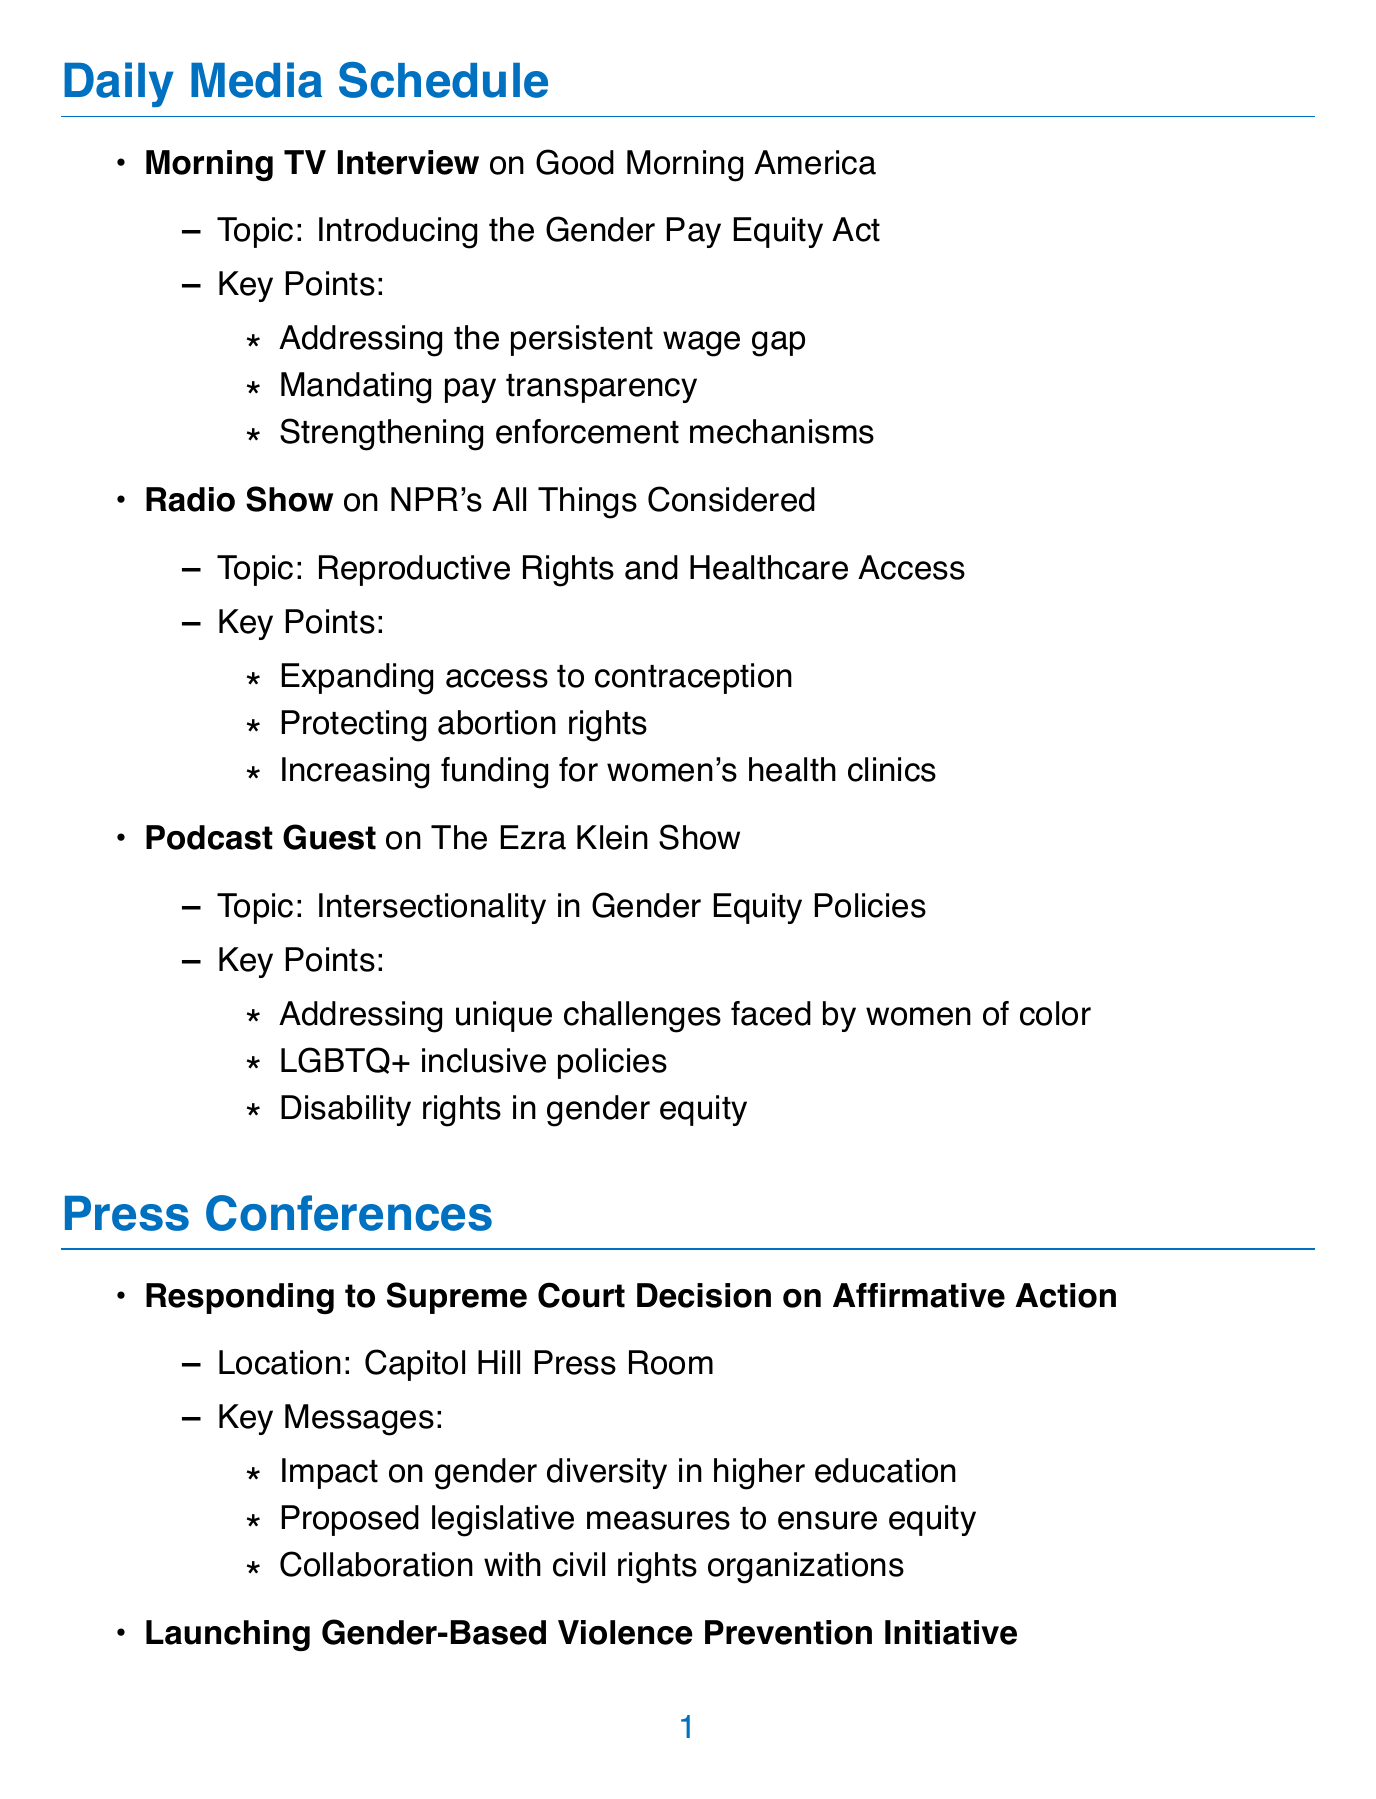what is the first media appearance listed? The first media appearance is a Morning TV Interview on Good Morning America.
Answer: Morning TV Interview on Good Morning America what is the key topic of the radio show? The key topic of the radio show is Reproductive Rights and Healthcare Access.
Answer: Reproductive Rights and Healthcare Access where is the press conference on the Supreme Court decision held? The press conference on the Supreme Court decision is held at Capitol Hill Press Room.
Answer: Capitol Hill Press Room what are the focus points in the podcast guest segment? The focus points in the podcast guest segment include addressing unique challenges faced by women of color, LGBTQ+ inclusive policies, and disability rights in gender equity.
Answer: Addressing unique challenges faced by women of color, LGBTQ+ inclusive policies, and disability rights in gender equity which social media platform is used to respond to the tech company lawsuit? The social media platform used to respond to the tech company lawsuit is the Official Twitter Account.
Answer: Official Twitter Account what initiative is launched at the women's rights historical park? The initiative launched at the women's rights historical park is the Gender-Based Violence Prevention Initiative.
Answer: Gender-Based Violence Prevention Initiative how many response points are presented for the International Women's Day event? Three response points are presented for the International Women's Day event.
Answer: Three what is discussed regarding the Annual Gender Gap Report? The discussion includes analyzing key findings and trends, connecting data to ongoing legislative efforts, and engaging constituents in dialogue about local impact.
Answer: Analyzing key findings and trends, connecting data to ongoing legislative efforts, and engaging constituents in dialogue about local impact 